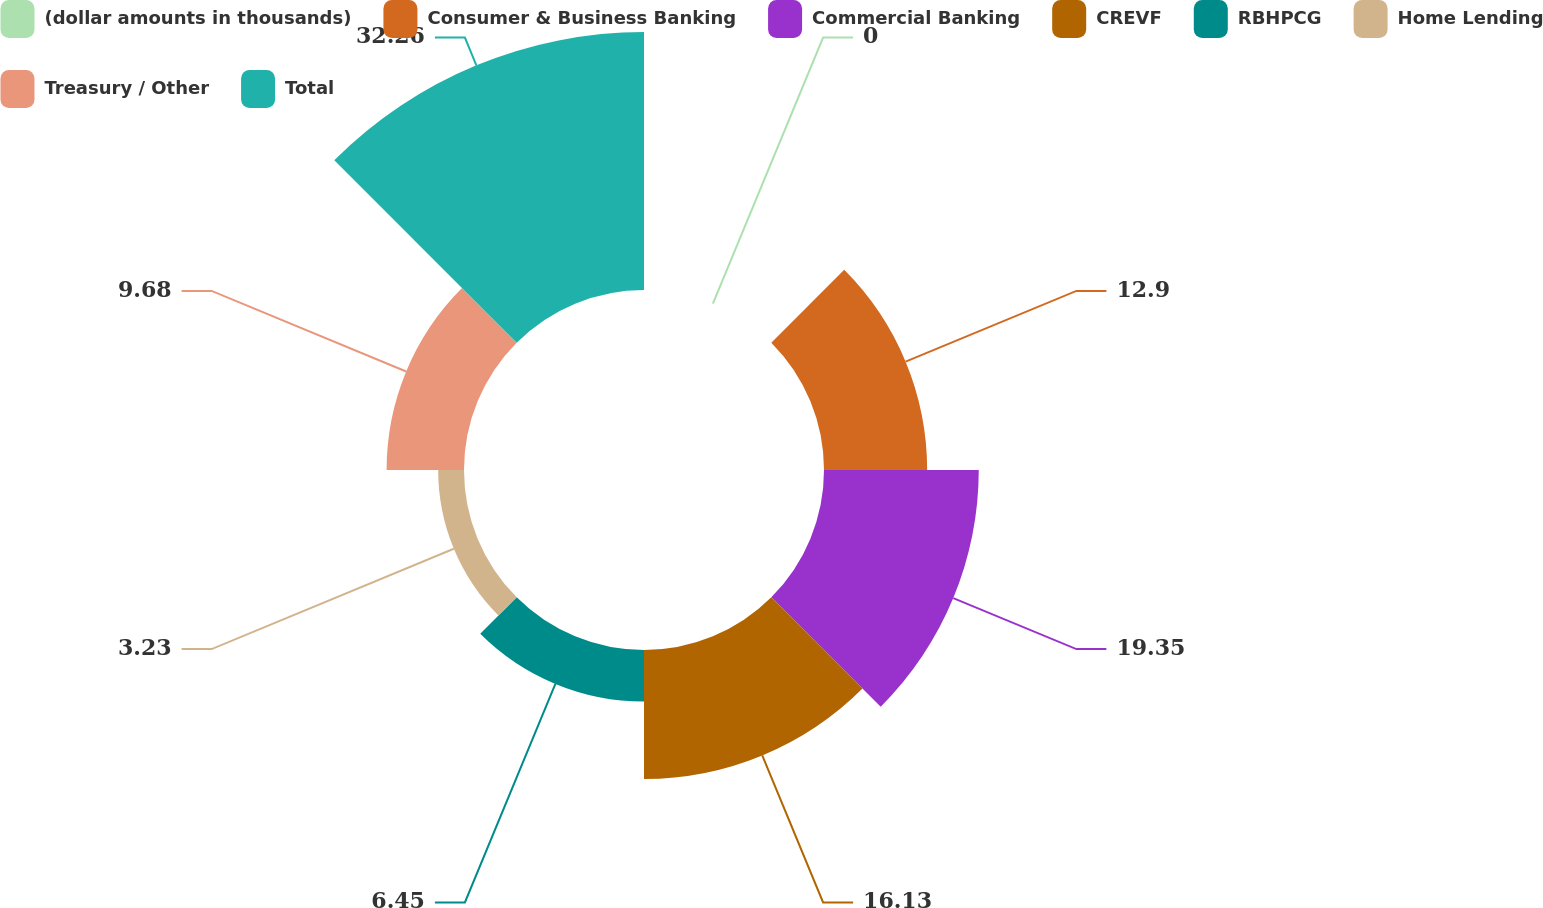Convert chart to OTSL. <chart><loc_0><loc_0><loc_500><loc_500><pie_chart><fcel>(dollar amounts in thousands)<fcel>Consumer & Business Banking<fcel>Commercial Banking<fcel>CREVF<fcel>RBHPCG<fcel>Home Lending<fcel>Treasury / Other<fcel>Total<nl><fcel>0.0%<fcel>12.9%<fcel>19.35%<fcel>16.13%<fcel>6.45%<fcel>3.23%<fcel>9.68%<fcel>32.26%<nl></chart> 